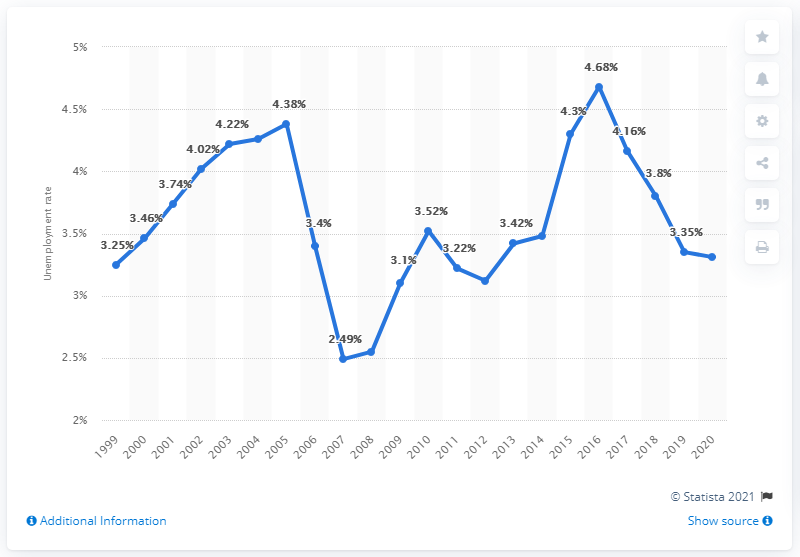What was the unemployment rate in Norway in 2020?
 3.31 